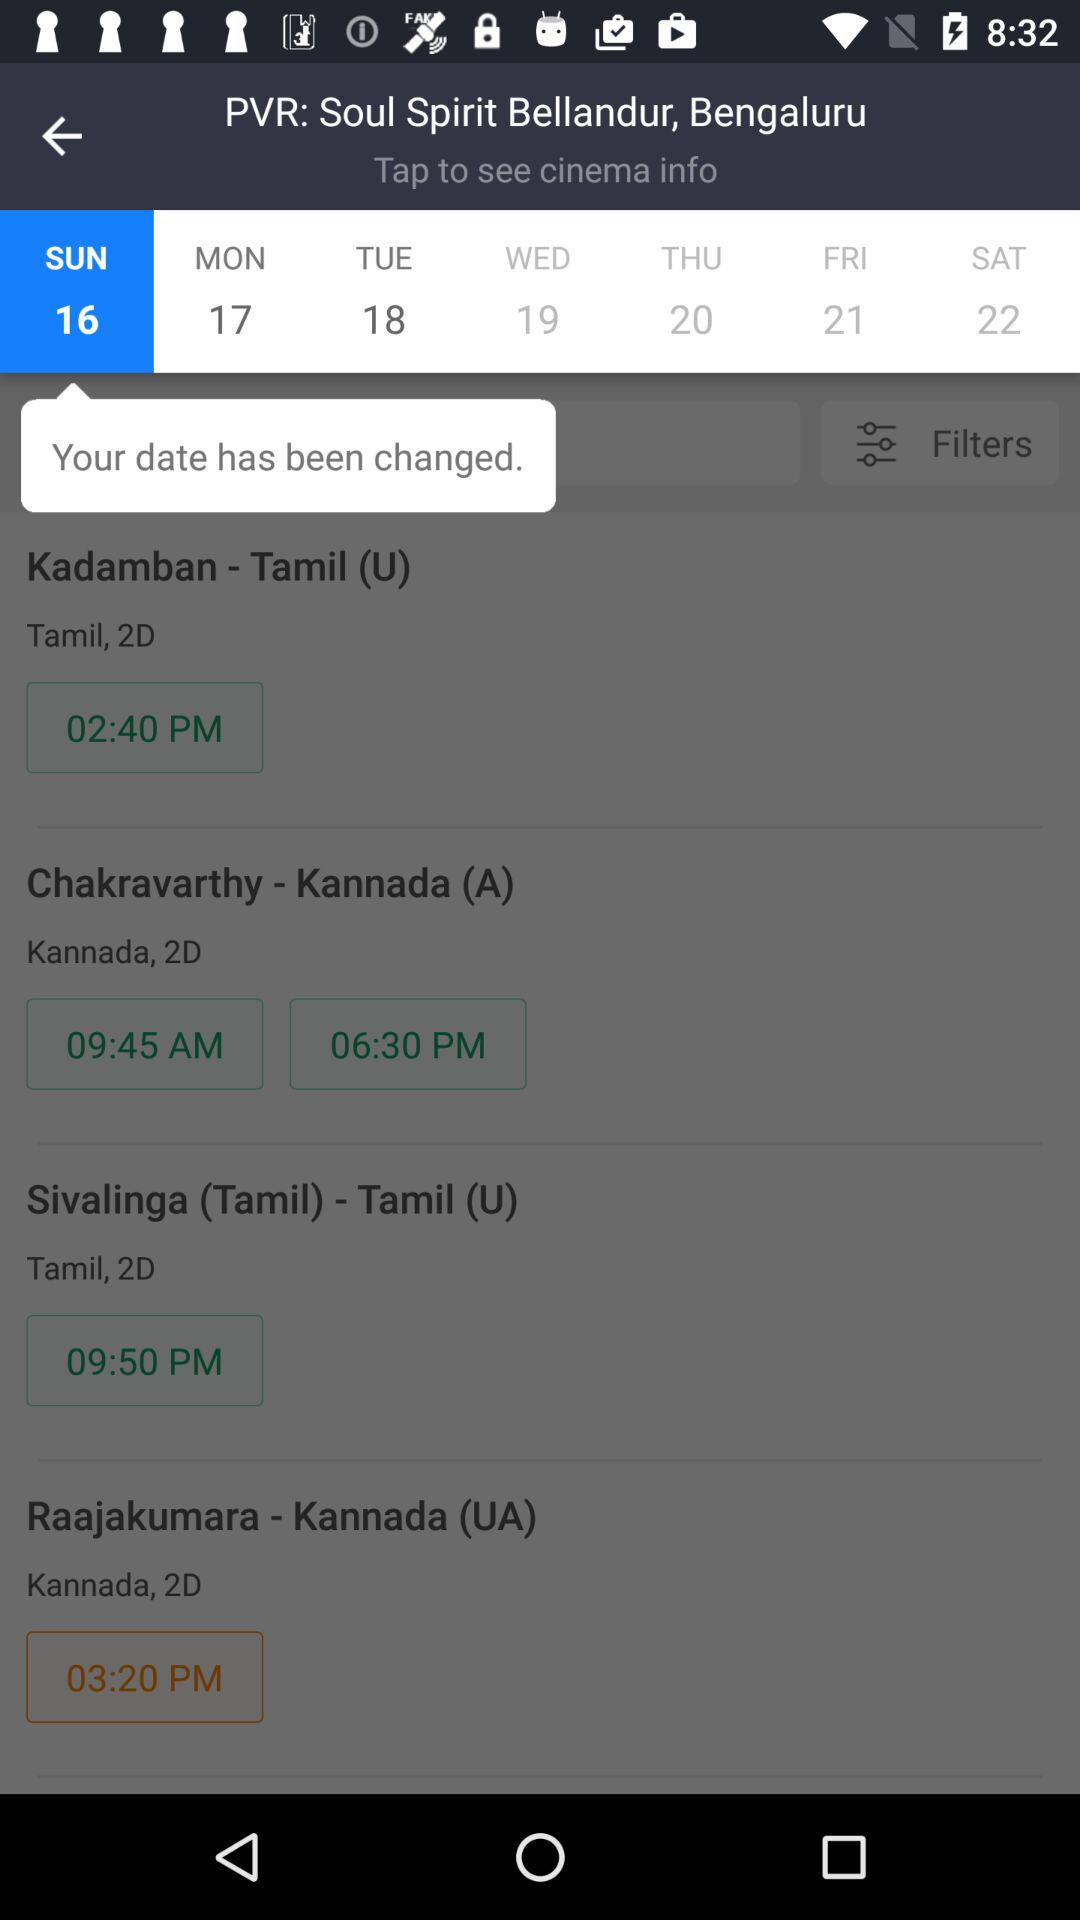Which movies are in Kannada language? The movies in Kannada language are "Chakravarthy" and "Raajakumara". 